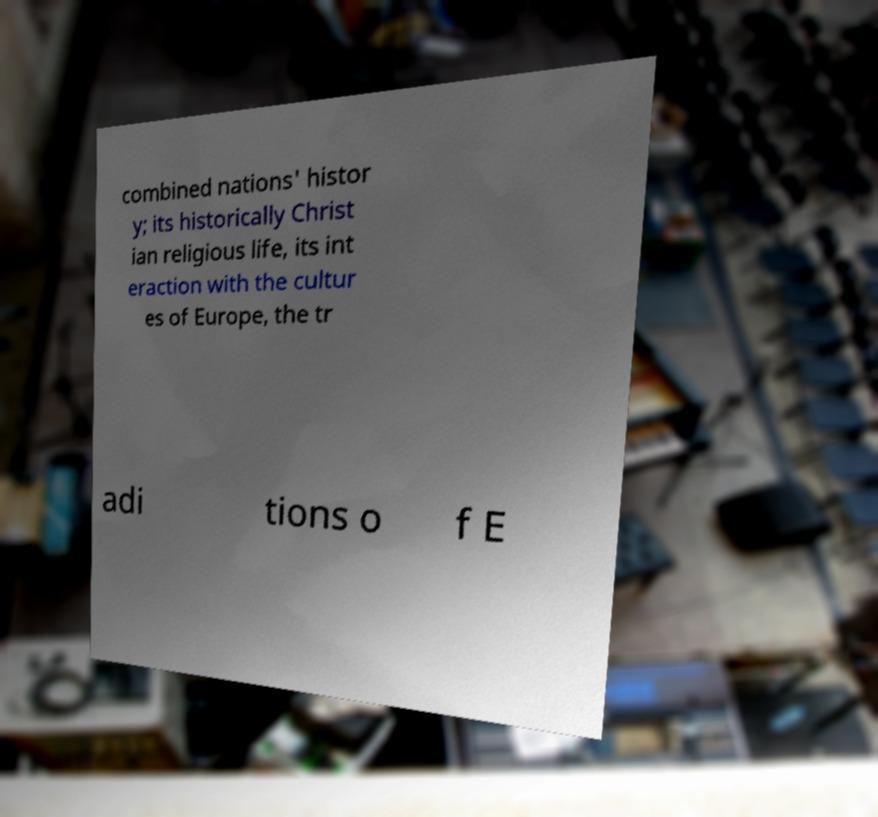Please identify and transcribe the text found in this image. combined nations' histor y; its historically Christ ian religious life, its int eraction with the cultur es of Europe, the tr adi tions o f E 